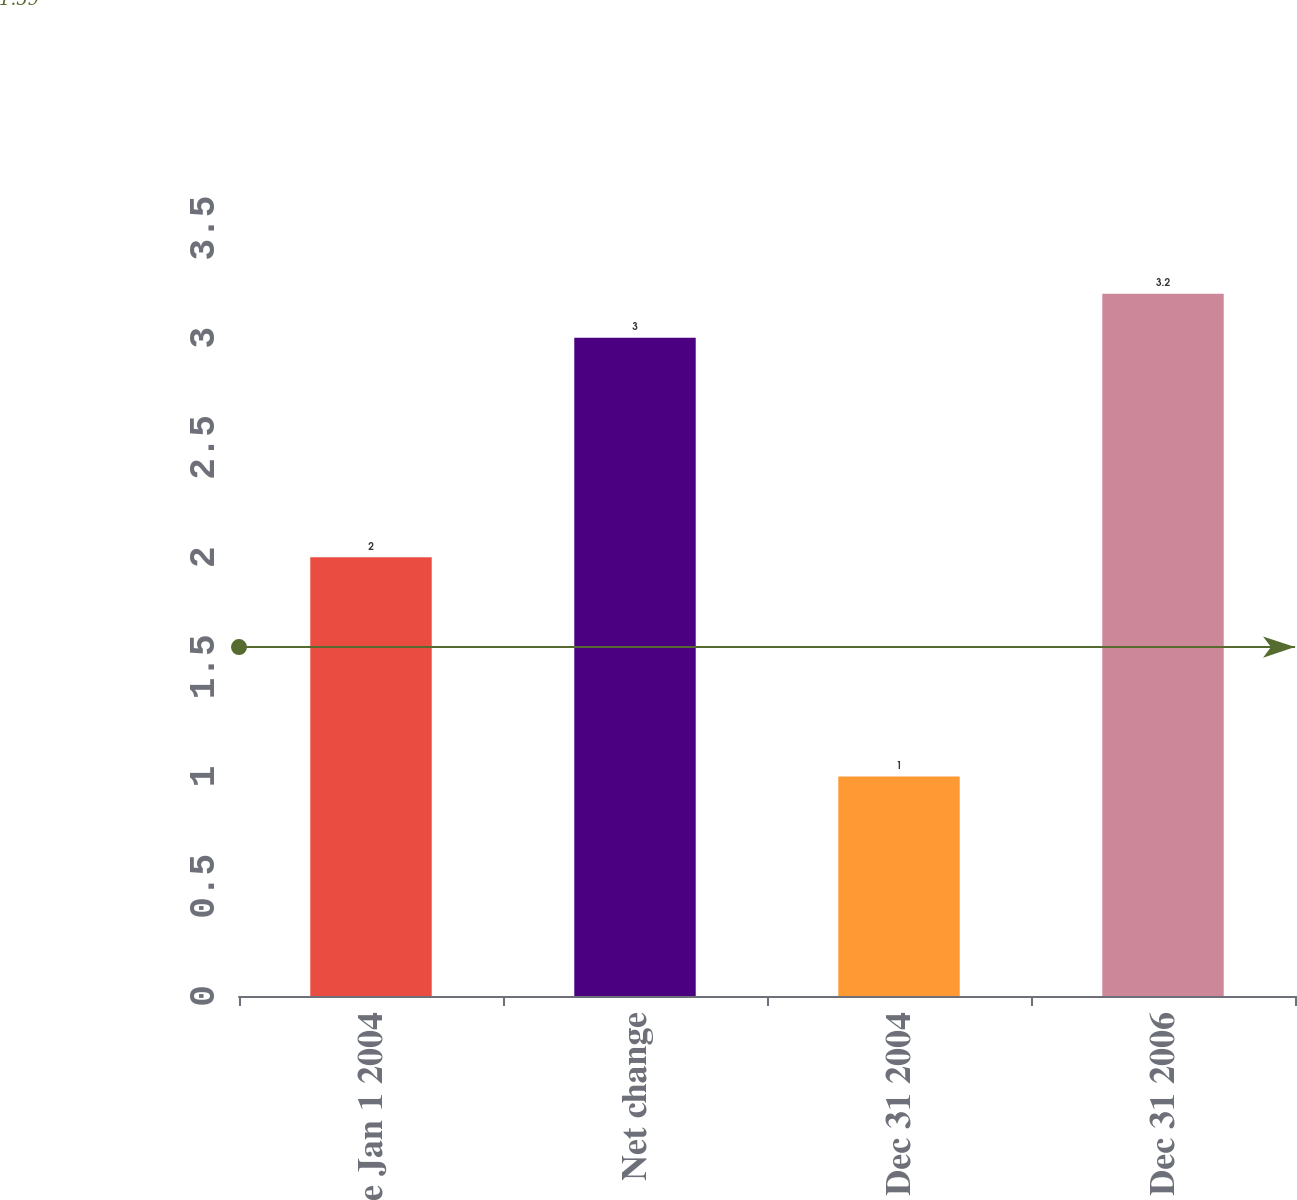Convert chart. <chart><loc_0><loc_0><loc_500><loc_500><bar_chart><fcel>Balance Jan 1 2004<fcel>Net change<fcel>Balance Dec 31 2004<fcel>Balance Dec 31 2006<nl><fcel>2<fcel>3<fcel>1<fcel>3.2<nl></chart> 